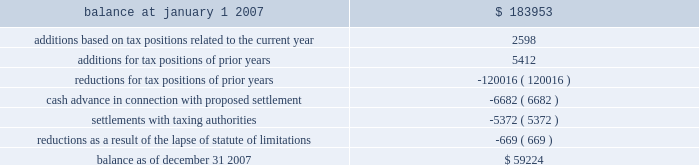American tower corporation and subsidiaries notes to consolidated financial statements 2014 ( continued ) company is currently unable to estimate the impact of the amount of such changes , if any , to previously recorded uncertain tax positions .
A reconciliation of the beginning and ending amount of unrecognized tax benefits for the year ending december 31 , 2007 is as follows ( in thousands ) : .
During the year ended december 31 , 2007 , the company recorded penalties and tax-related interest income of $ 2.5 million and interest income from tax refunds of $ 1.5 million for the year ended december 31 , 2007 .
As of december 31 , 2007 and january 1 , 2007 , the total unrecognized tax benefits included in other long-term liabilities in the consolidated balance sheets was $ 29.6 million and $ 34.3 million , respectively .
As of december 31 , 2007 and january 1 , 2007 , the total amount of accrued income tax-related interest and penalties included in other long-term liabilities in the consolidated balance sheets was $ 30.7 million and $ 33.2 million , respectively .
In the fourth quarter of 2007 , the company entered into a tax amnesty program with the mexican tax authority .
As of december 31 , 2007 , the company had met all of the administrative requirements of the program , which enabled the company to recognize certain tax benefits .
This was confirmed by the mexican tax authority on february 5 , 2008 .
These benefits include a reduction of uncertain tax benefits of $ 5.4 million along with penalties and interest of $ 12.5 million related to 2002 , all of which reduced income tax expense .
In connection with the above program , the company paid $ 6.7 million to the mexican tax authority as a settlement offer for other uncertain tax positions related to 2003 and 2004 .
This offer is currently under review by the mexican tax authority ; the company cannot yet determine the specific timing or the amount of any potential settlement .
During 2007 , the statute of limitations on certain unrecognized tax benefits lapsed , which resulted in a $ 0.7 million decrease in the liability for uncertain tax benefits , all of which reduced the income tax provision .
The company files numerous consolidated and separate income tax returns , including u.s .
Federal and state tax returns and foreign tax returns in mexico and brazil .
As a result of the company 2019s ability to carry forward federal and state net operating losses , the applicable tax years remain open to examination until three years after the applicable loss carryforwards have been used or expired .
However , the company has completed u.s .
Federal income tax examinations for tax years up to and including 2002 .
The company is currently undergoing u.s .
Federal income tax examinations for tax years 2004 and 2005 .
Additionally , it is subject to examinations in various u.s .
State jurisdictions for certain tax years , and is under examination in brazil for the 2001 through 2006 tax years and mexico for the 2002 tax year .
Sfas no .
109 , 201caccounting for income taxes , 201d requires that companies record a valuation allowance when it is 201cmore likely than not that some portion or all of the deferred tax assets will not be realized . 201d at december 31 , 2007 , the company has provided a valuation allowance of approximately $ 88.2 million , including approximately .
What is the percentage change in he total amount of accrued income tax-related interest and penalties included in other long-term liabilities during 2007? 
Computations: ((30.7 - 33.2) / 33.2)
Answer: -0.0753. 